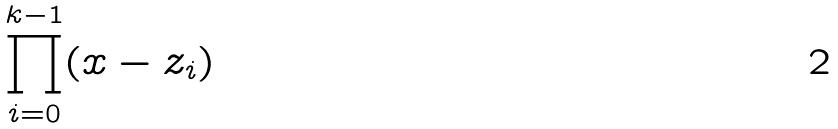Convert formula to latex. <formula><loc_0><loc_0><loc_500><loc_500>\prod _ { i = 0 } ^ { k - 1 } ( x - z _ { i } )</formula> 